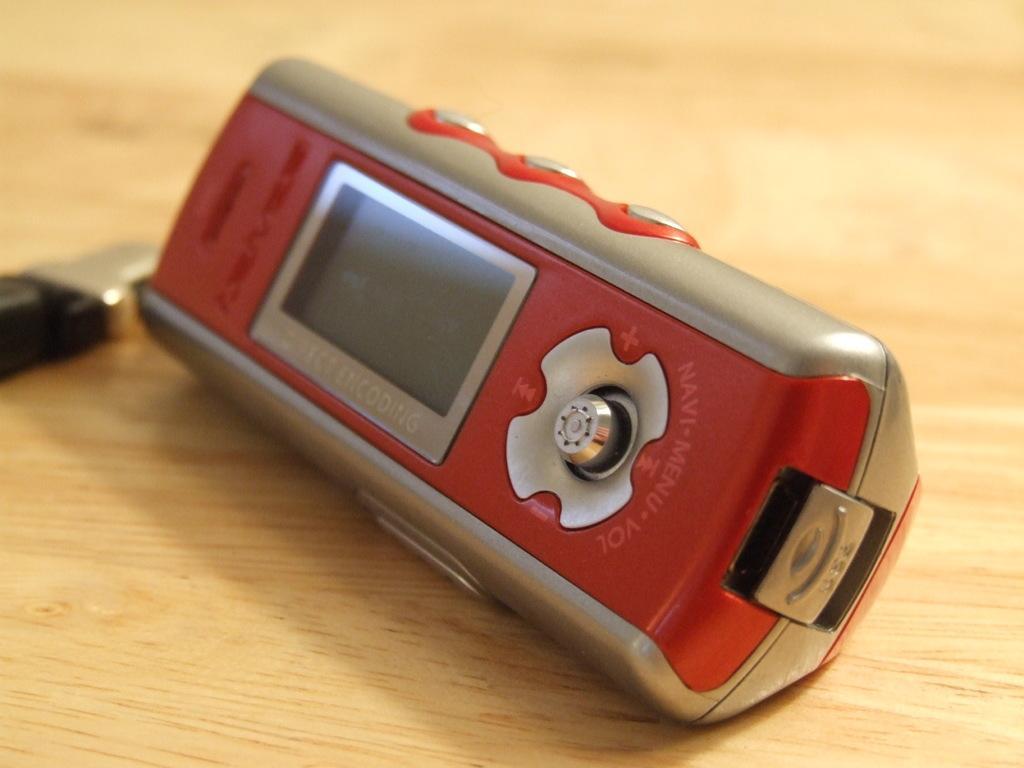Describe this image in one or two sentences. In this picture we can see a device and this device is on a table. 